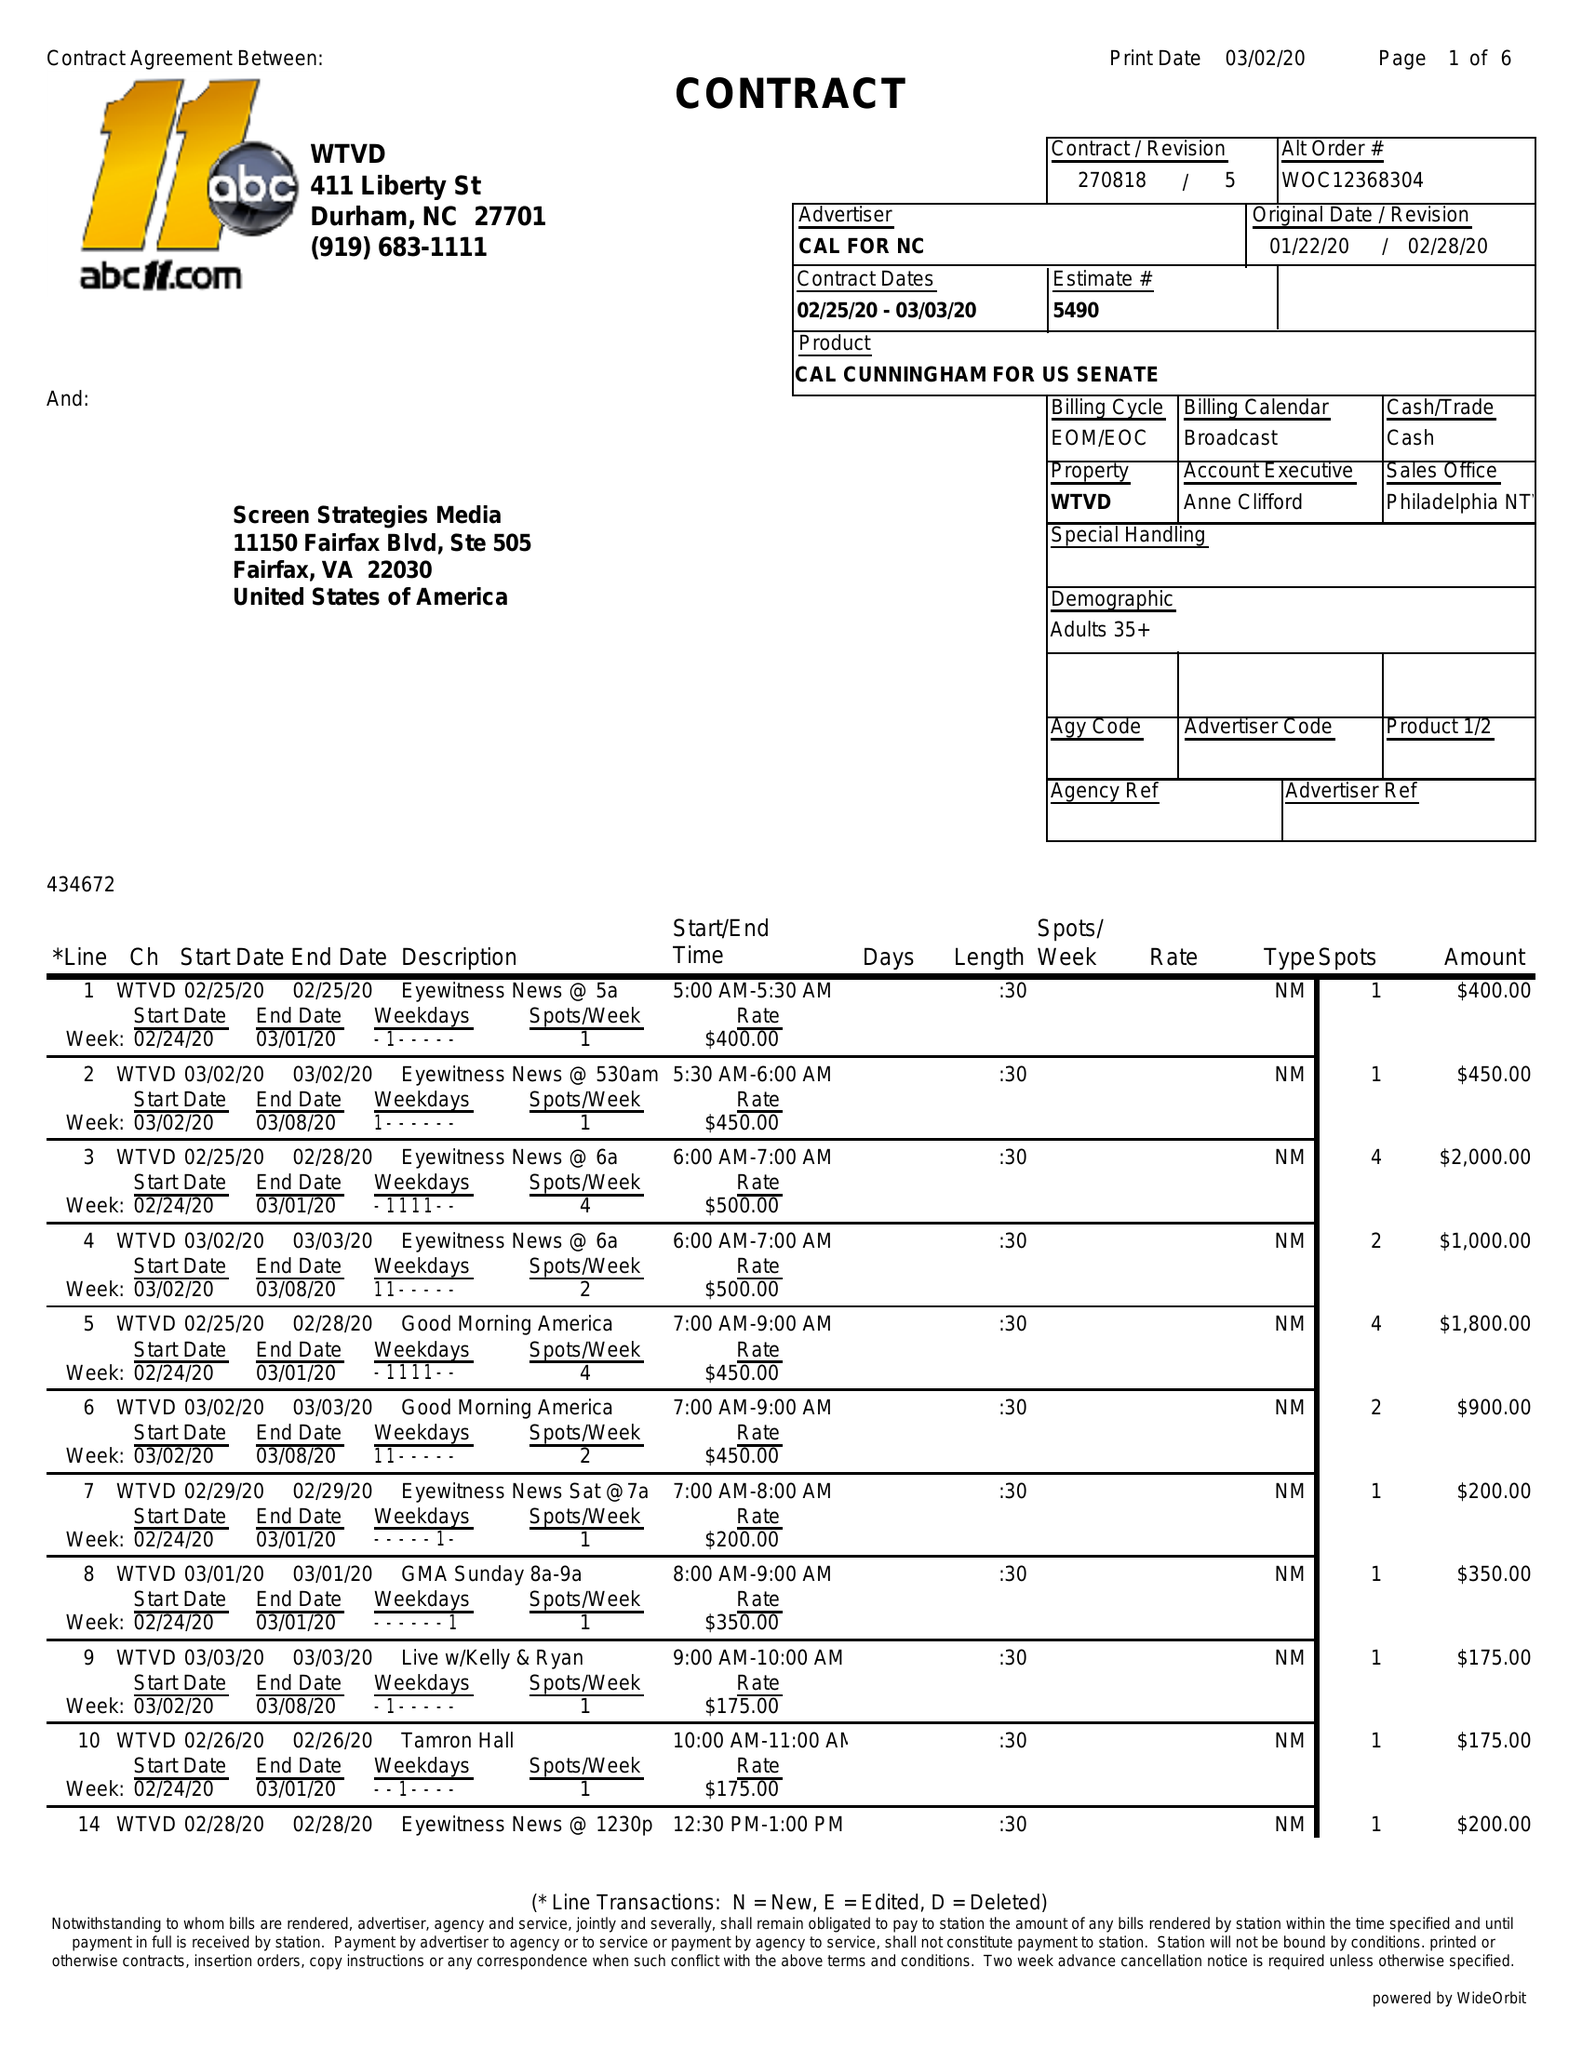What is the value for the contract_num?
Answer the question using a single word or phrase. 270818/5 